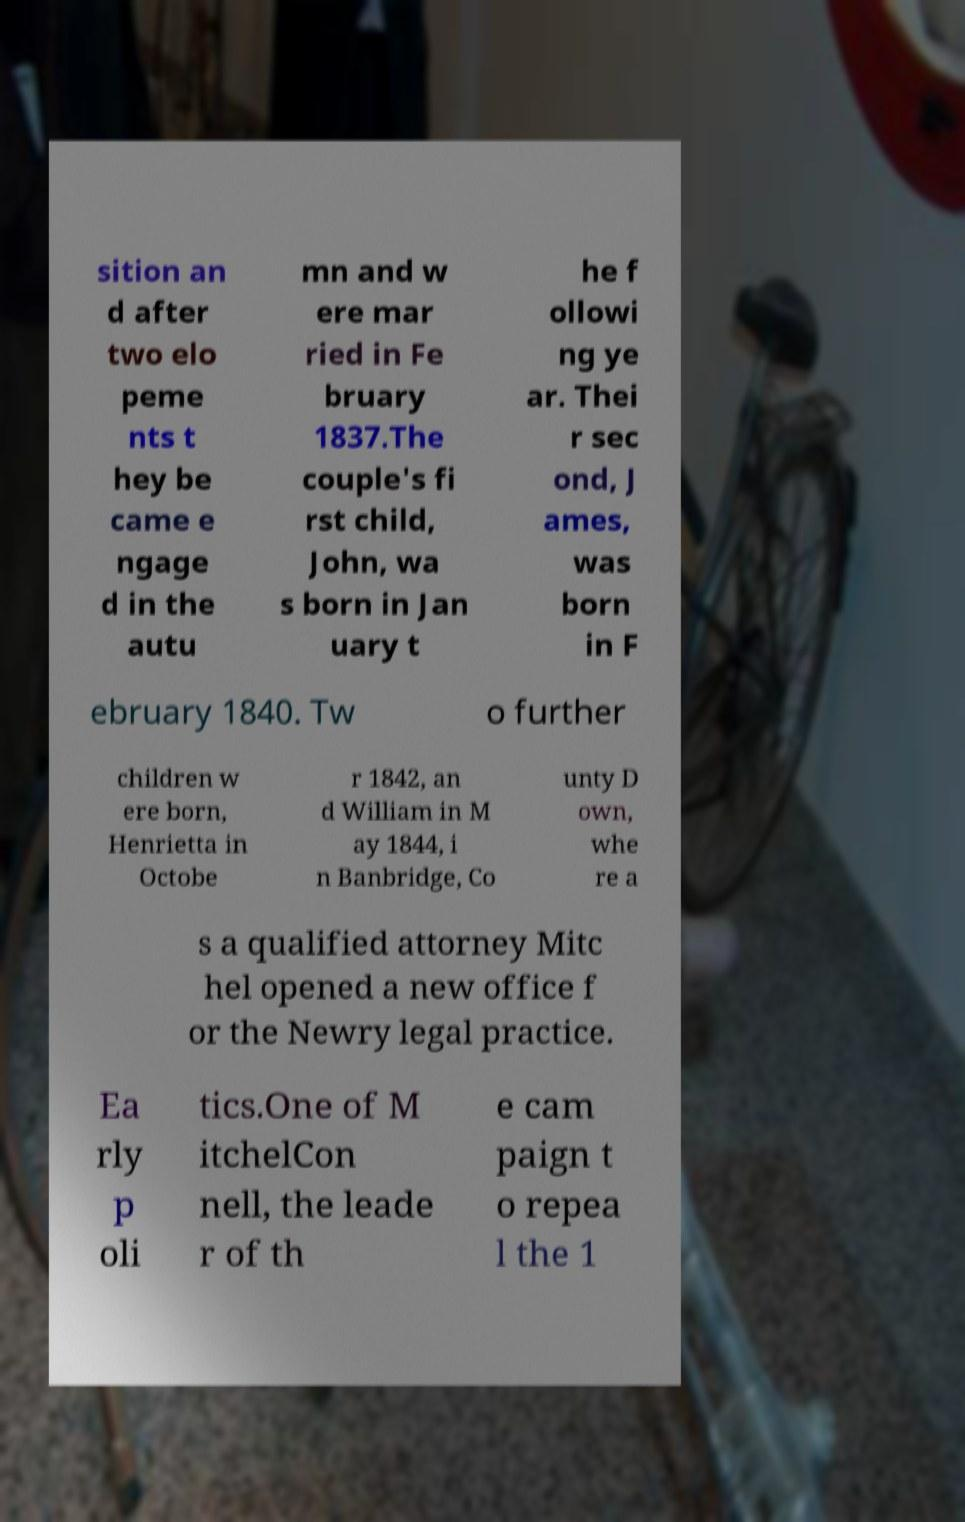I need the written content from this picture converted into text. Can you do that? sition an d after two elo peme nts t hey be came e ngage d in the autu mn and w ere mar ried in Fe bruary 1837.The couple's fi rst child, John, wa s born in Jan uary t he f ollowi ng ye ar. Thei r sec ond, J ames, was born in F ebruary 1840. Tw o further children w ere born, Henrietta in Octobe r 1842, an d William in M ay 1844, i n Banbridge, Co unty D own, whe re a s a qualified attorney Mitc hel opened a new office f or the Newry legal practice. Ea rly p oli tics.One of M itchelCon nell, the leade r of th e cam paign t o repea l the 1 